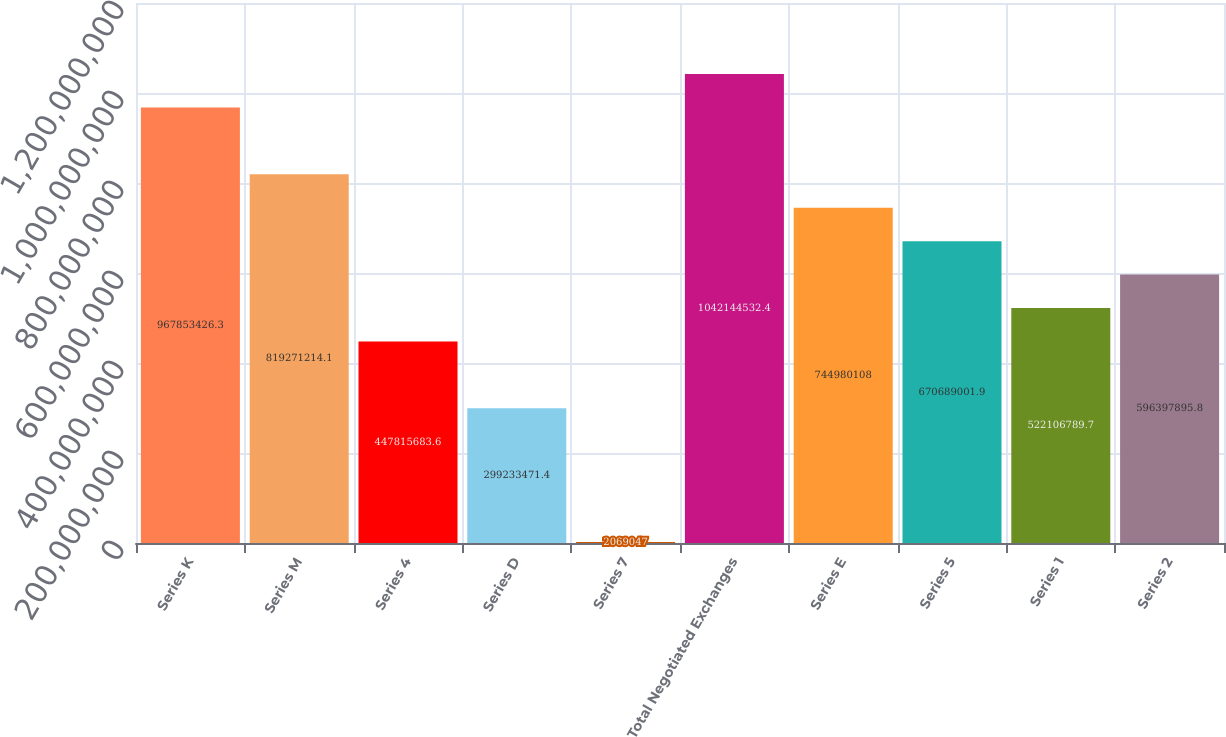Convert chart to OTSL. <chart><loc_0><loc_0><loc_500><loc_500><bar_chart><fcel>Series K<fcel>Series M<fcel>Series 4<fcel>Series D<fcel>Series 7<fcel>Total Negotiated Exchanges<fcel>Series E<fcel>Series 5<fcel>Series 1<fcel>Series 2<nl><fcel>9.67853e+08<fcel>8.19271e+08<fcel>4.47816e+08<fcel>2.99233e+08<fcel>2.06905e+06<fcel>1.04214e+09<fcel>7.4498e+08<fcel>6.70689e+08<fcel>5.22107e+08<fcel>5.96398e+08<nl></chart> 